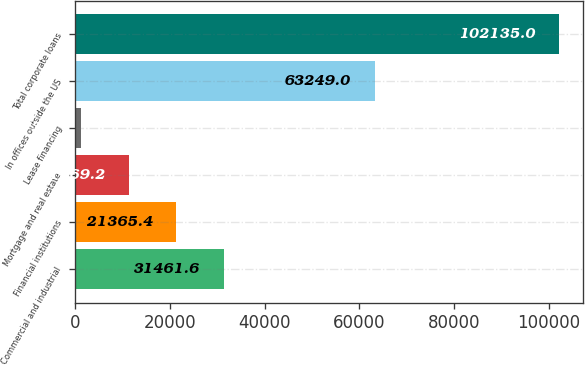<chart> <loc_0><loc_0><loc_500><loc_500><bar_chart><fcel>Commercial and industrial<fcel>Financial institutions<fcel>Mortgage and real estate<fcel>Lease financing<fcel>In offices outside the US<fcel>Total corporate loans<nl><fcel>31461.6<fcel>21365.4<fcel>11269.2<fcel>1173<fcel>63249<fcel>102135<nl></chart> 